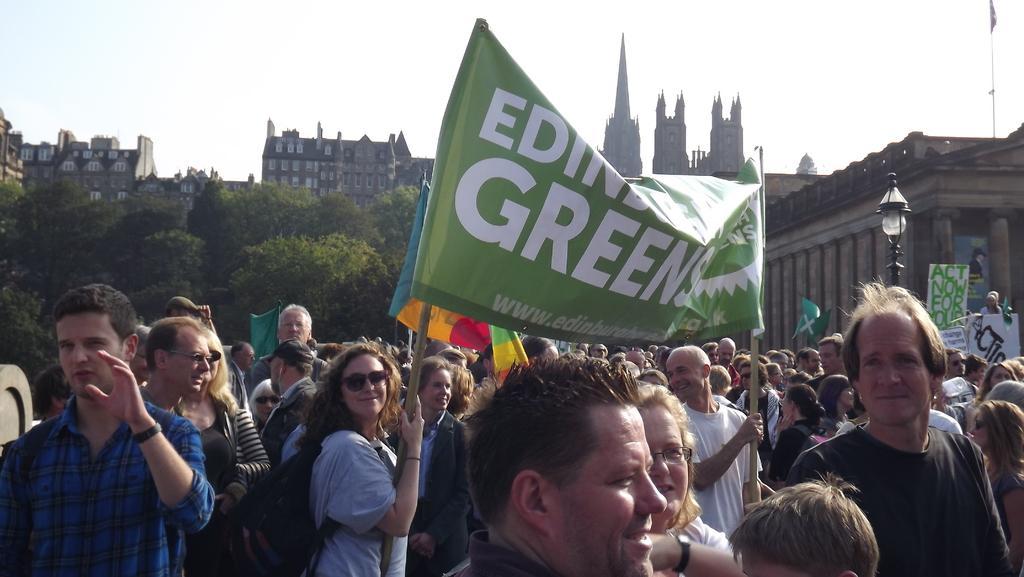Can you describe this image briefly? In the center of the image there are people standing and there are two persons holding a banner. In the background of the image there are trees. There are buildings. 